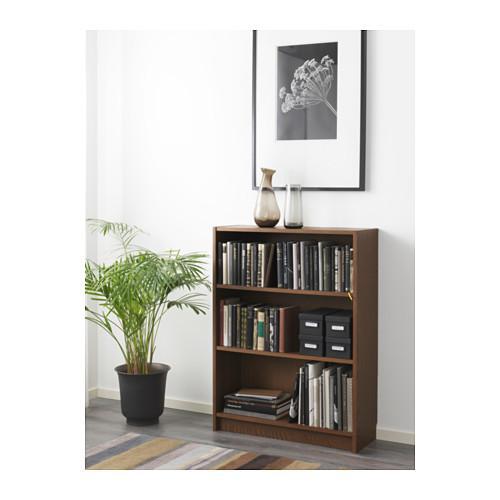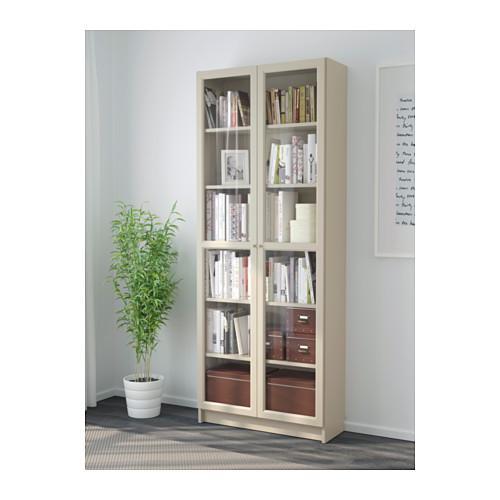The first image is the image on the left, the second image is the image on the right. For the images displayed, is the sentence "A potted plant stands to the left of a bookshelf in each image." factually correct? Answer yes or no. Yes. The first image is the image on the left, the second image is the image on the right. Evaluate the accuracy of this statement regarding the images: "One of the shelves is six rows tall.". Is it true? Answer yes or no. Yes. 